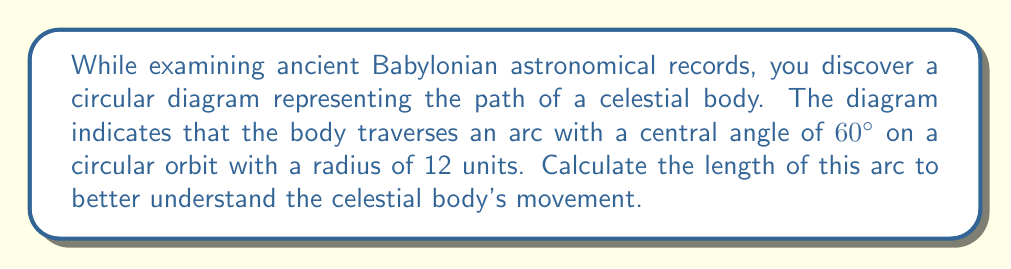Teach me how to tackle this problem. To solve this problem, we'll use the arc length formula:

$$s = r\theta$$

Where:
$s$ = arc length
$r$ = radius of the circle
$\theta$ = central angle in radians

Step 1: Convert the central angle from degrees to radians.
$60°$ in radians = $60° \times \frac{\pi}{180°} = \frac{\pi}{3}$ radians

Step 2: Apply the arc length formula:
$$s = r\theta$$
$$s = 12 \times \frac{\pi}{3}$$

Step 3: Simplify:
$$s = 4\pi$$

Therefore, the length of the arc is $4\pi$ units.
Answer: $4\pi$ units 